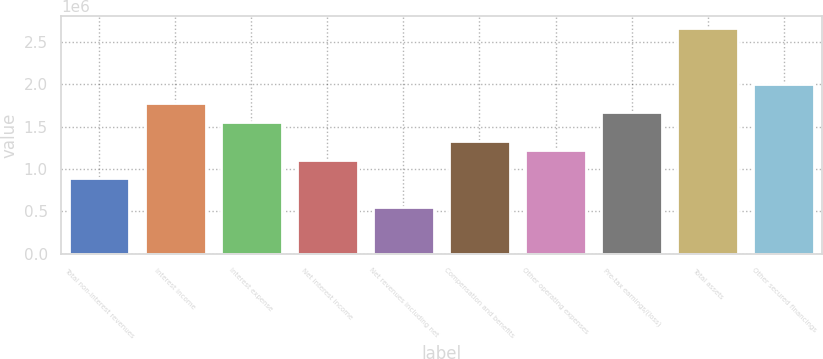<chart> <loc_0><loc_0><loc_500><loc_500><bar_chart><fcel>Total non-interest revenues<fcel>Interest income<fcel>Interest expense<fcel>Net interest income<fcel>Net revenues including net<fcel>Compensation and benefits<fcel>Other operating expenses<fcel>Pre-tax earnings/(loss)<fcel>Total assets<fcel>Other secured financings<nl><fcel>889780<fcel>1.77956e+06<fcel>1.55711e+06<fcel>1.11223e+06<fcel>556114<fcel>1.33467e+06<fcel>1.22345e+06<fcel>1.66834e+06<fcel>2.66934e+06<fcel>2.002e+06<nl></chart> 